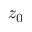Convert formula to latex. <formula><loc_0><loc_0><loc_500><loc_500>z _ { 0 }</formula> 